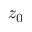Convert formula to latex. <formula><loc_0><loc_0><loc_500><loc_500>z _ { 0 }</formula> 